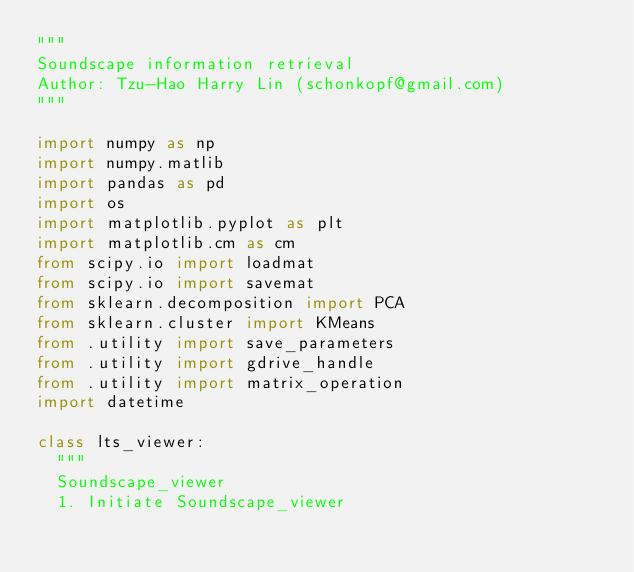Convert code to text. <code><loc_0><loc_0><loc_500><loc_500><_Python_>"""
Soundscape information retrieval
Author: Tzu-Hao Harry Lin (schonkopf@gmail.com)
"""

import numpy as np
import numpy.matlib
import pandas as pd
import os
import matplotlib.pyplot as plt
import matplotlib.cm as cm
from scipy.io import loadmat
from scipy.io import savemat
from sklearn.decomposition import PCA
from sklearn.cluster import KMeans
from .utility import save_parameters
from .utility import gdrive_handle
from .utility import matrix_operation
import datetime

class lts_viewer:
  """
  Soundscape_viewer
  1. Initiate Soundscape_viewer</code> 